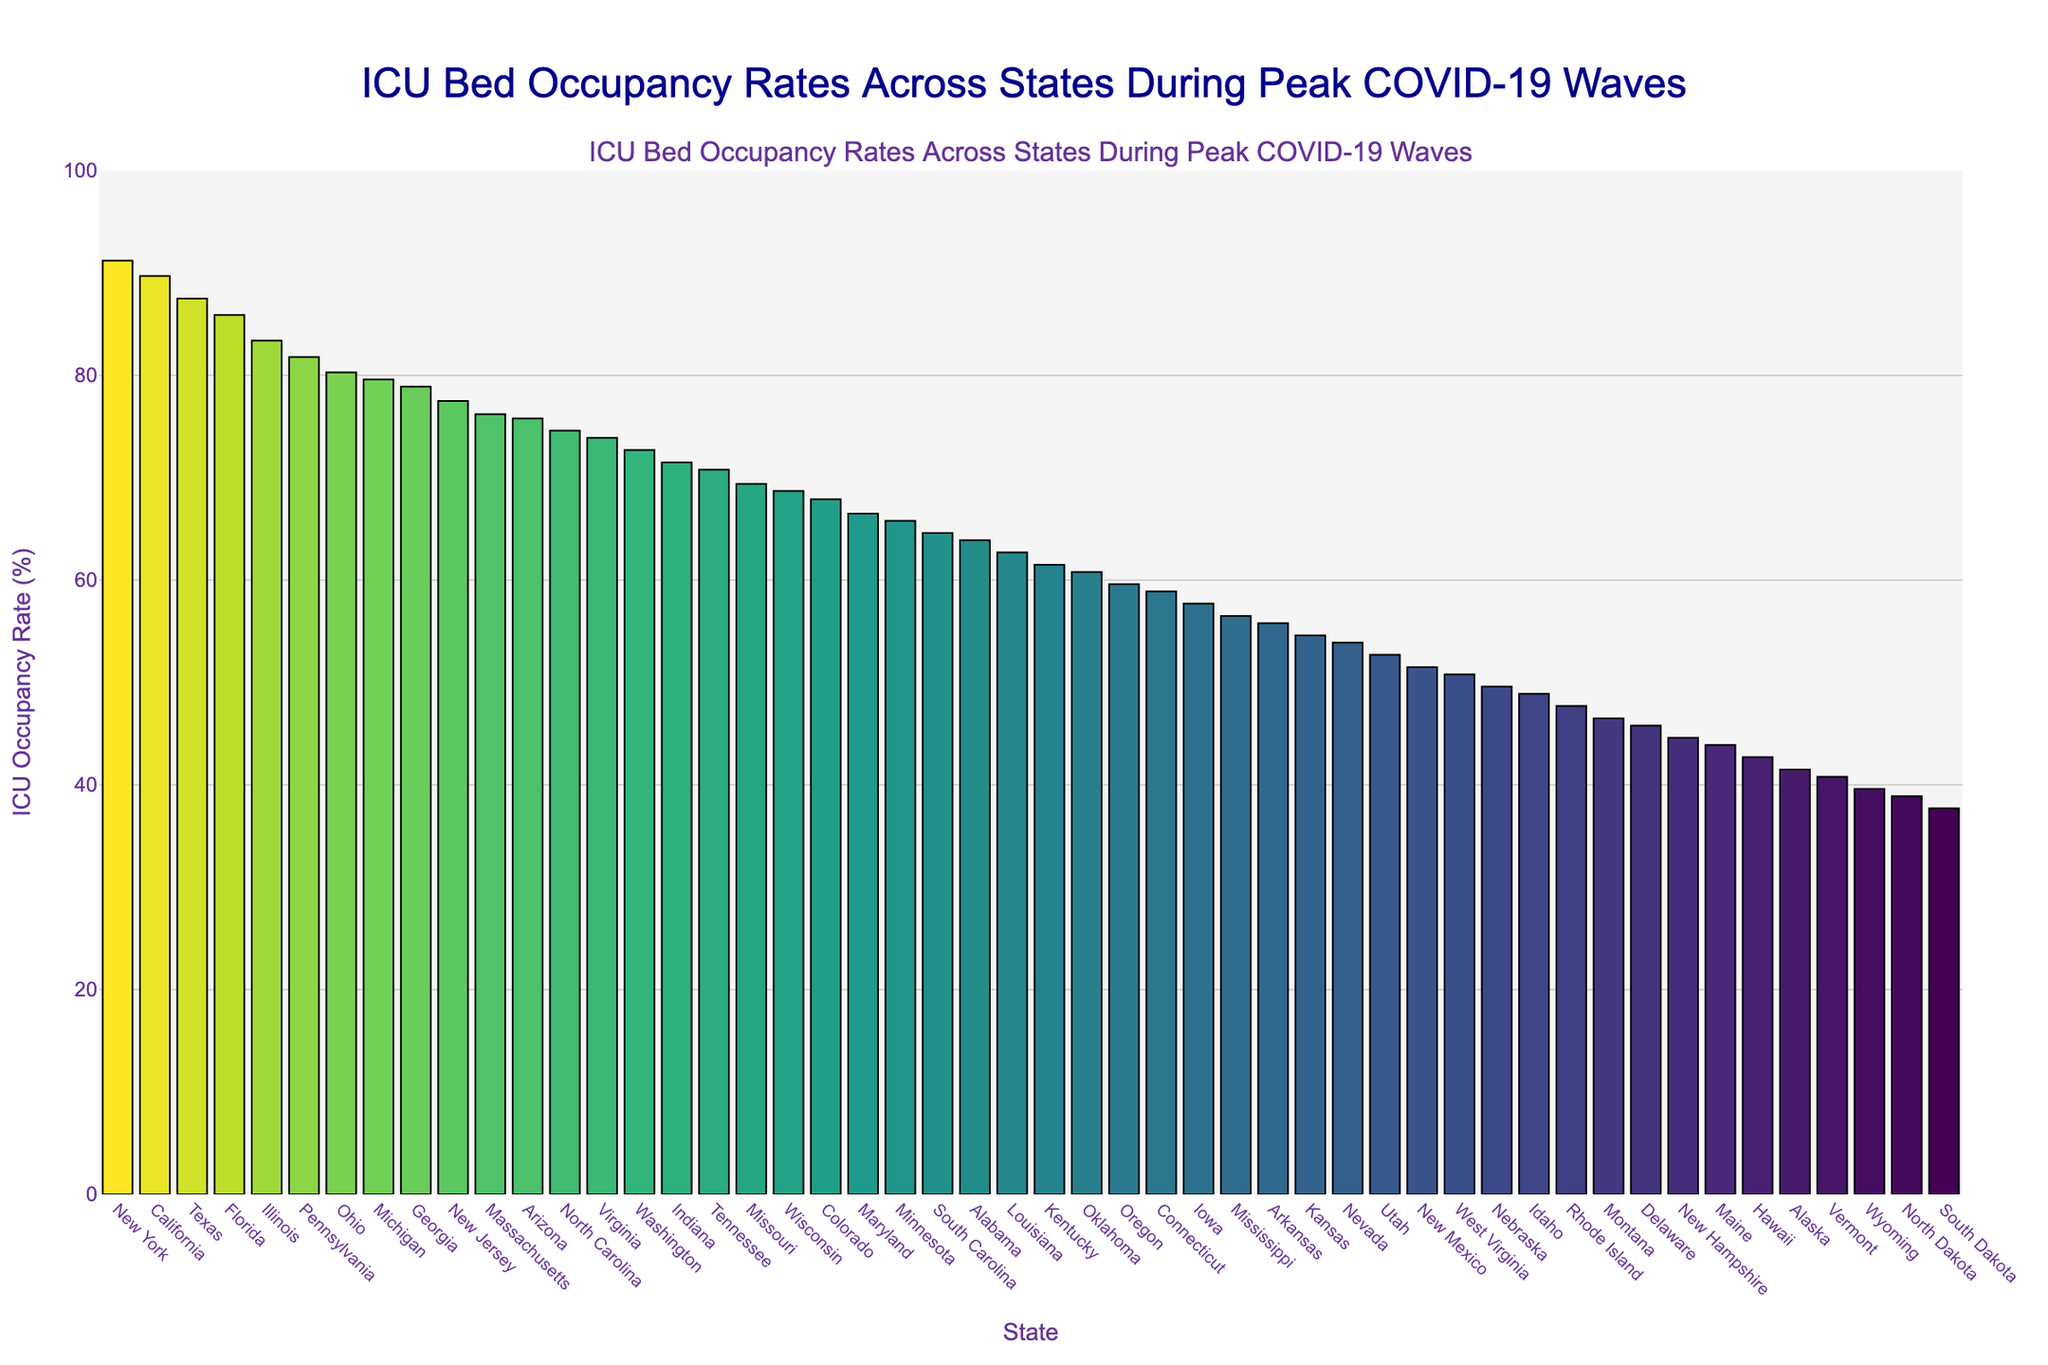What is the state with the highest ICU bed occupancy rate? To determine the state with the highest ICU bed occupancy rate, observe the bar that reaches the highest point on the plot. The height of each bar represents the ICU occupancy rate for each state. New York has the highest bar, indicating the highest ICU bed occupancy rate.
Answer: New York Which state has a lower ICU bed occupancy rate, Texas or Florida? To compare Texas and Florida, look at the heights of their respective bars. Texas has a higher occupancy rate at 87.5%, while Florida has a rate of 85.9%. Thus, Florida has the lower rate between the two.
Answer: Florida What is the difference in ICU bed occupancy rates between California and Pennsylvania? Identify the bars for California and Pennsylvania and note their occupancy rates. California's rate is 89.7%, and Pennsylvania's rate is 81.8%. Subtract Pennsylvania's rate from California's rate to find the difference: 89.7% - 81.8% = 7.9%.
Answer: 7.9% Which region's ICU bed occupancy is close to the median value? To find the median, arrange the states' ICU bed occupancy rates in ascending order. The median value will be the middle value. Since there are 51 states, the median is the 26th value in this list, which is Kentucky with an occupancy rate of 61.5%. The bar for Kentucky is in the midpoint of the sorted bars on the chart, suggesting it is the median.
Answer: Kentucky How many states have an ICU bed occupancy rate greater than 80%? Count the number of bars that exceed the 80% mark on the y-axis. The states are: New York, California, Texas, Florida, Illinois, Pennsylvania, and Ohio. Thus, there are seven such states.
Answer: 7 Compare the ICU bed occupancy rates of Ohio and Michigan. Which state has a higher rate? Look at the bars for Ohio and Michigan. Ohio's rate is 80.3%, while Michigan's rate is 79.6%. Therefore, Ohio has a slightly higher occupancy rate.
Answer: Ohio What is the average ICU bed occupancy rate for the top three states? First, identify the top three states with the highest occupancy rates: New York (91.2%), California (89.7%), and Texas (87.5%). Calculate the average by summing these rates and dividing by three: (91.2% + 89.7% + 87.5%) / 3 = 89.47%.
Answer: 89.47% Which state has the lowest ICU bed occupancy rate, and what is it? The state with the lowest ICU bed occupancy rate will have the shortest bar. North Dakota, with an occupancy rate of 37.7%, has the shortest bar.
Answer: North Dakota What are the visual cues that indicate the states with higher ICU bed occupancy rates? States with higher ICU bed occupancy rates are represented by taller bars, and these bars are often colored in darker shades according to the Viridis colorscale that transitions from light to dark as the values increase. Taller and darker bars indicate higher occupancy rates.
Answer: Taller and darker-colored bars What's the difference in ICU bed occupancy rates between the highest and lowest states? Observe the highest (New York, 91.2%) and the lowest (North Dakota, 37.7%) occupancies. Subtract the lowest rate from the highest rate: 91.2% - 37.7% = 53.5%.
Answer: 53.5% 